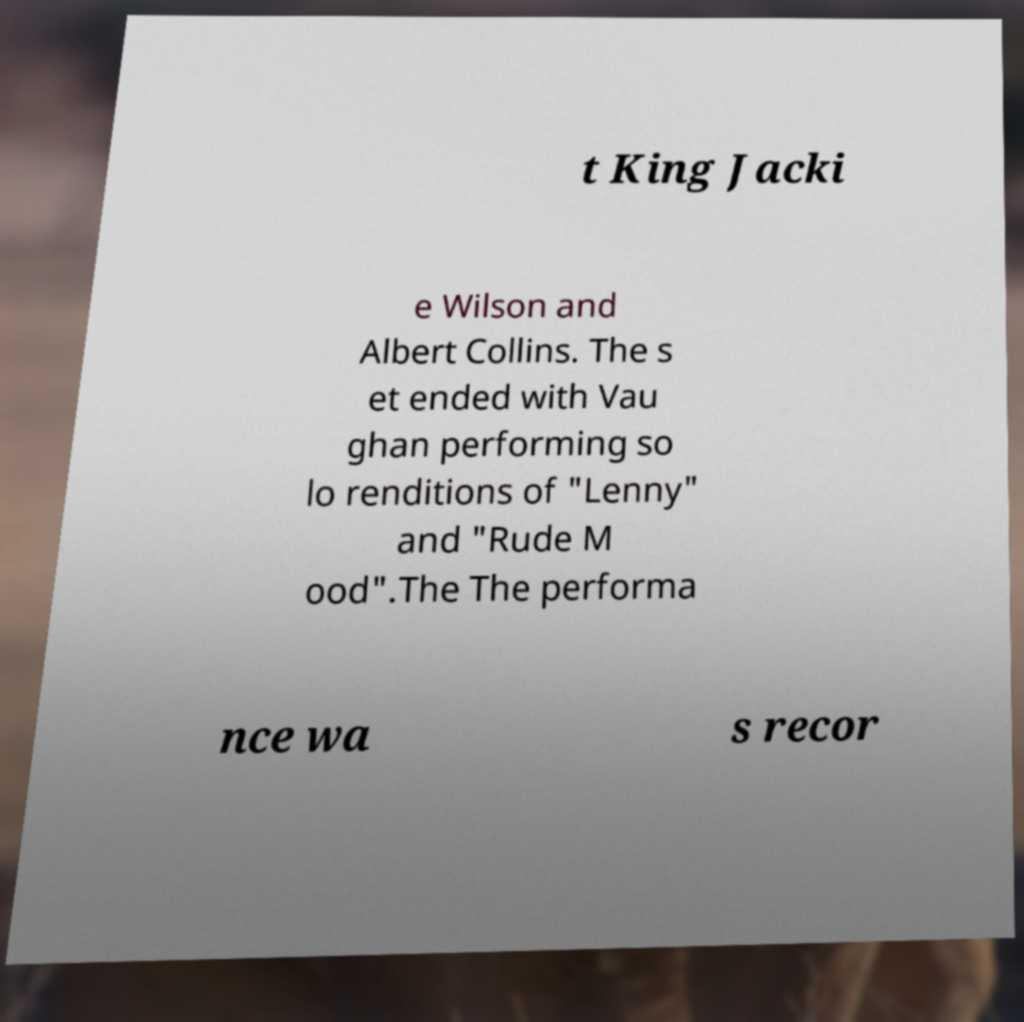I need the written content from this picture converted into text. Can you do that? t King Jacki e Wilson and Albert Collins. The s et ended with Vau ghan performing so lo renditions of "Lenny" and "Rude M ood".The The performa nce wa s recor 